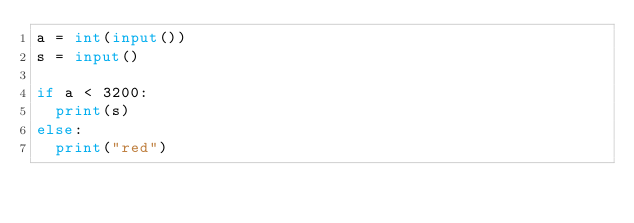<code> <loc_0><loc_0><loc_500><loc_500><_Python_>a = int(input())
s = input()

if a < 3200:
  print(s)
else:
  print("red")</code> 